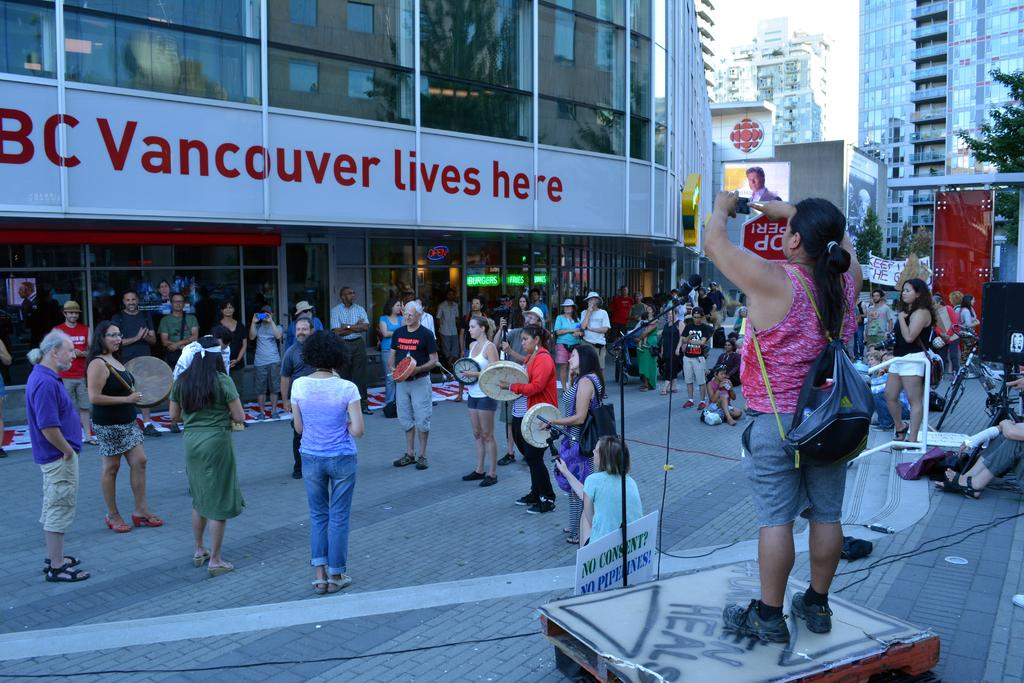How many people are in the image? There are people in the image, but the exact number is not specified. What is one person doing in the image? One person is standing and holding a gadget. What is the person holding the gadget wearing? The person holding the gadget is wearing a bag. What are some other people doing in the image? There are people holding musical instruments. What can be seen in the background of the image? There are buildings, trees, and banners in the background of the image. What type of flower is being knitted with yarn in the image? There is no flower or yarn present in the image. Is there a hill visible in the background of the image? There is no hill mentioned in the facts provided for the image. 